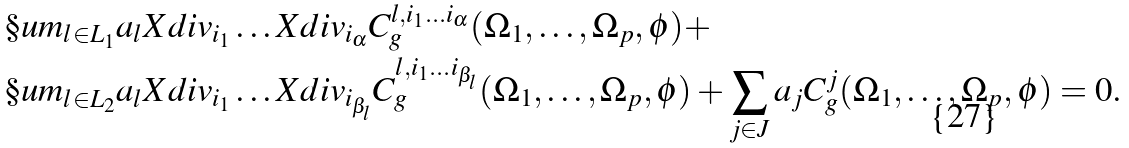Convert formula to latex. <formula><loc_0><loc_0><loc_500><loc_500>& \S u m _ { l \in L _ { 1 } } a _ { l } X d i v _ { i _ { 1 } } \dots X d i v _ { i _ { \alpha } } C ^ { l , i _ { 1 } \dots i _ { \alpha } } _ { g } ( \Omega _ { 1 } , \dots , \Omega _ { p } , \phi ) + \\ & \S u m _ { l \in L _ { 2 } } a _ { l } X d i v _ { i _ { 1 } } \dots X d i v _ { i _ { \beta _ { l } } } C ^ { l , i _ { 1 } \dots i _ { \beta _ { l } } } _ { g } ( \Omega _ { 1 } , \dots , \Omega _ { p } , \phi ) + \sum _ { j \in J } a _ { j } C ^ { j } _ { g } ( \Omega _ { 1 } , \dots , \Omega _ { p } , \phi ) = 0 .</formula> 